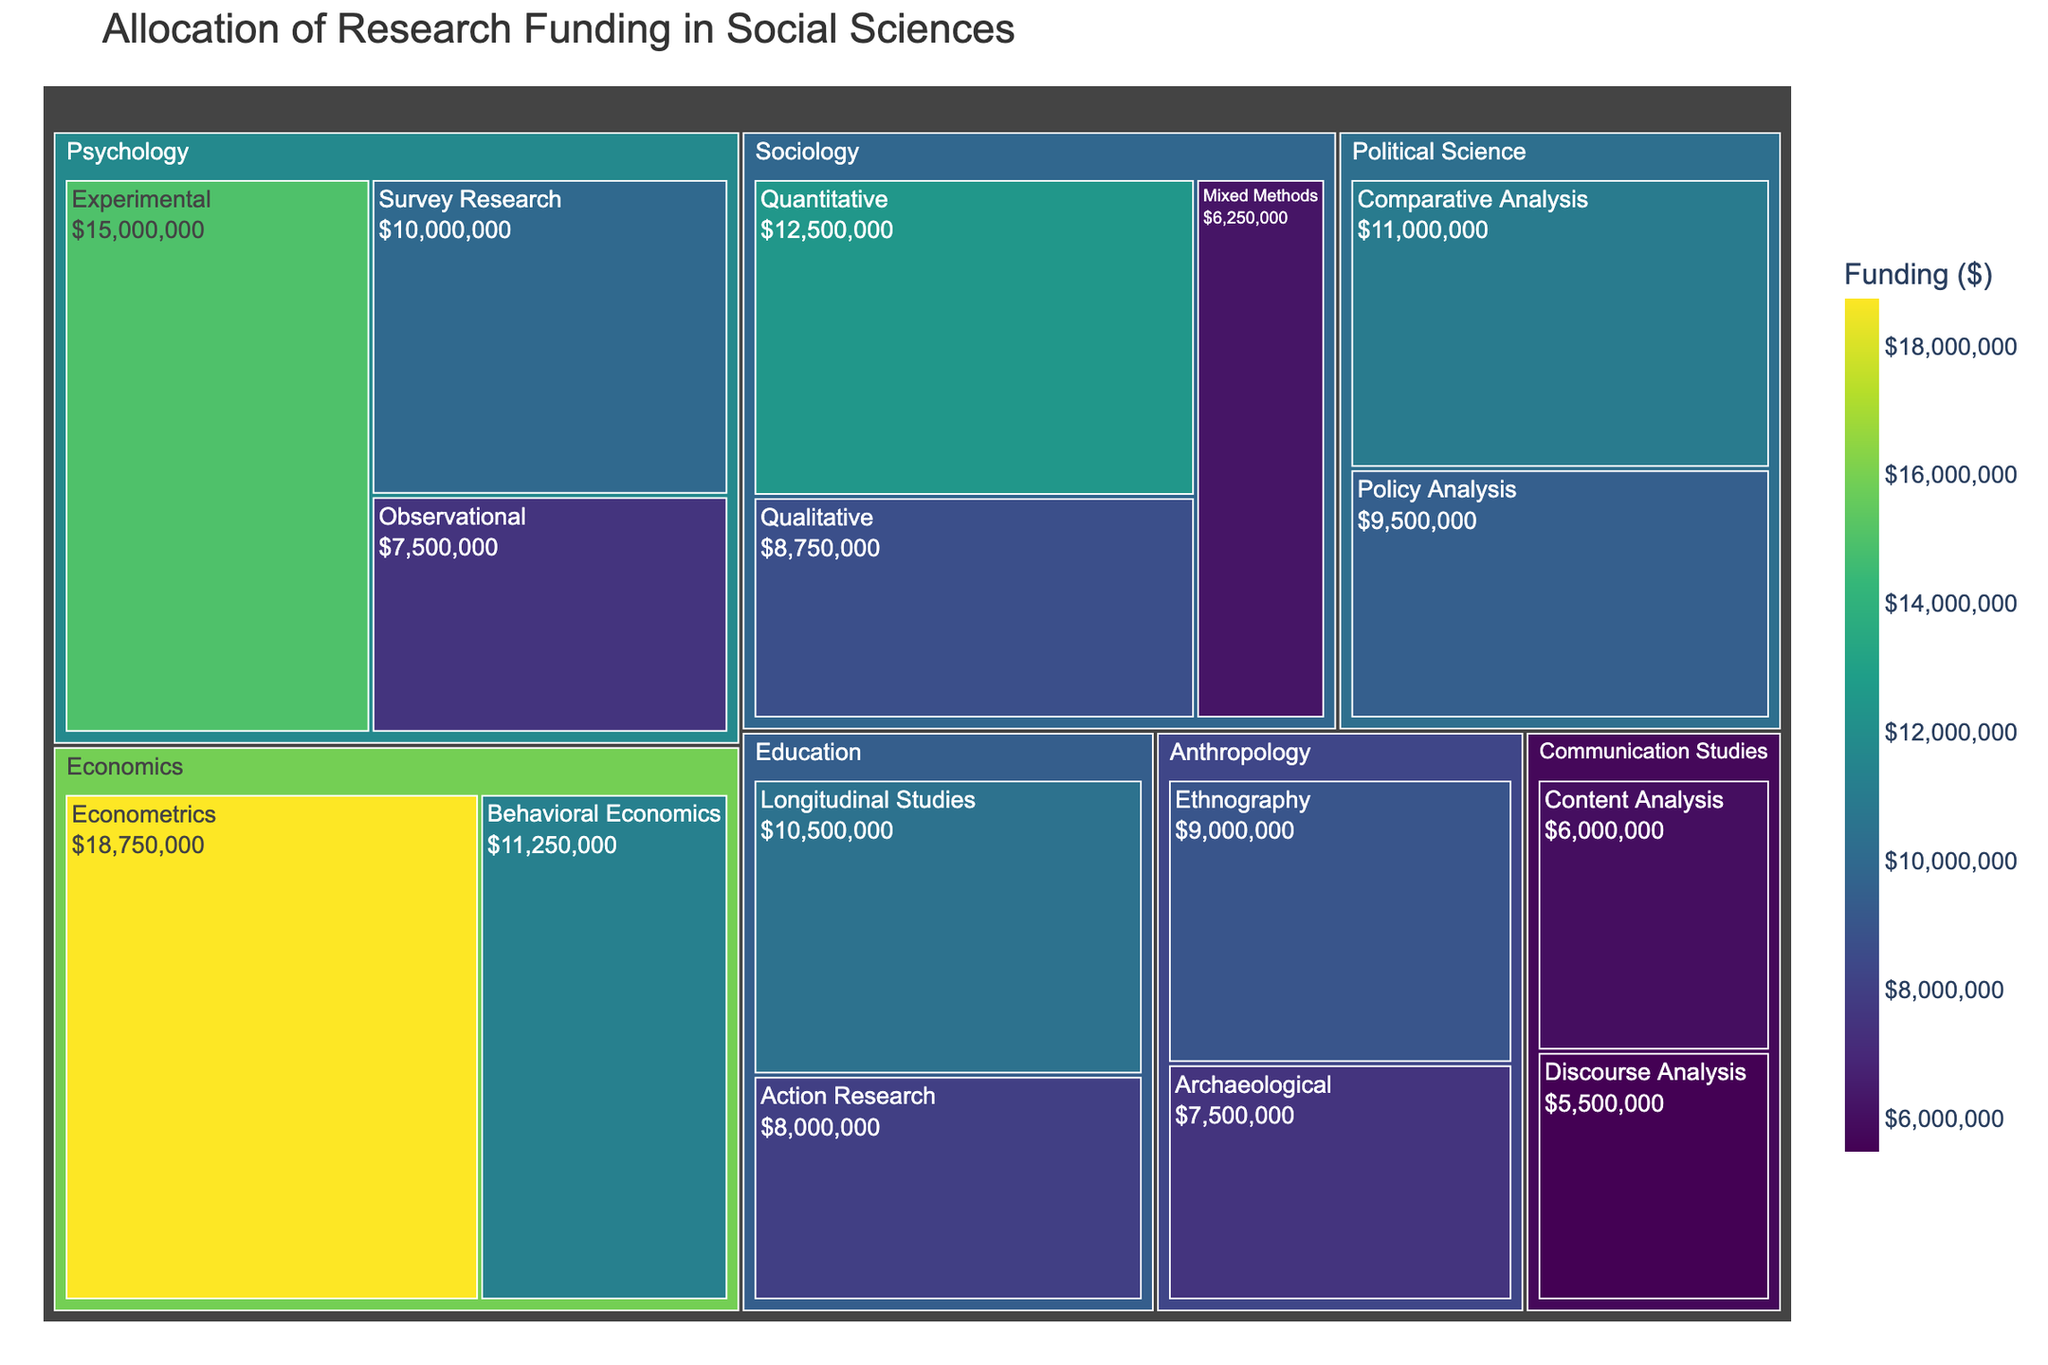What is the title of the treemap? The title of the treemap is displayed at the top of the figure. It summarizes what the visual representation is about.
Answer: Allocation of Research Funding in Social Sciences Which methodology in Sociology received the most funding? By examining the Sociological methodologies in the treemap, the one with the largest slice indicates the most funding.
Answer: Quantitative How much funding was allocated to Psychology, and what proportion of that was for Experimental methodology? Add the funding for all methodologies within Psychology and compare it to the funding for Experimental methodology. The proportion can be calculated by dividing the Experimental funding by total Psychology funding.
Answer: Psychology total funding = $15000000 + $7500000 + $10000000 = $32500000; Proportion for Experimental = $15000000 / $32500000 = ~46.2% Which discipline received more funding, Anthropology or Communication Studies? Sum up the funding of all methodologies in Anthropology and Communication Studies, respectively, and compare the totals.
Answer: Anthropology What is the funding difference between Policy Analysis in Political Science and Action Research in Education? Retrieve the funding amounts for Policy Analysis in Political Science and Action Research in Education and calculate their difference by subtraction.
Answer: $9500000 - $8000000 = $1500000 How is the funding for Econometrics in Economics compared to the total funding for Sociology? Extract the funding amount for Econometrics and compare it to the sum of all methodologies within Sociology.
Answer: Econometrics = $18750000; Sociology total = $12500000 + $8750000 + $6250000 = $27500000; Econometrics is less What discipline and methodology together received the single highest amount of funding? Look for the largest tile in the treemap over all disciplines and methodologies.
Answer: Psychology, Experimental What discipline has the smallest combined funding from all its methodologies? Sum the funding for each discipline and find the smallest total amount.
Answer: Communication Studies 